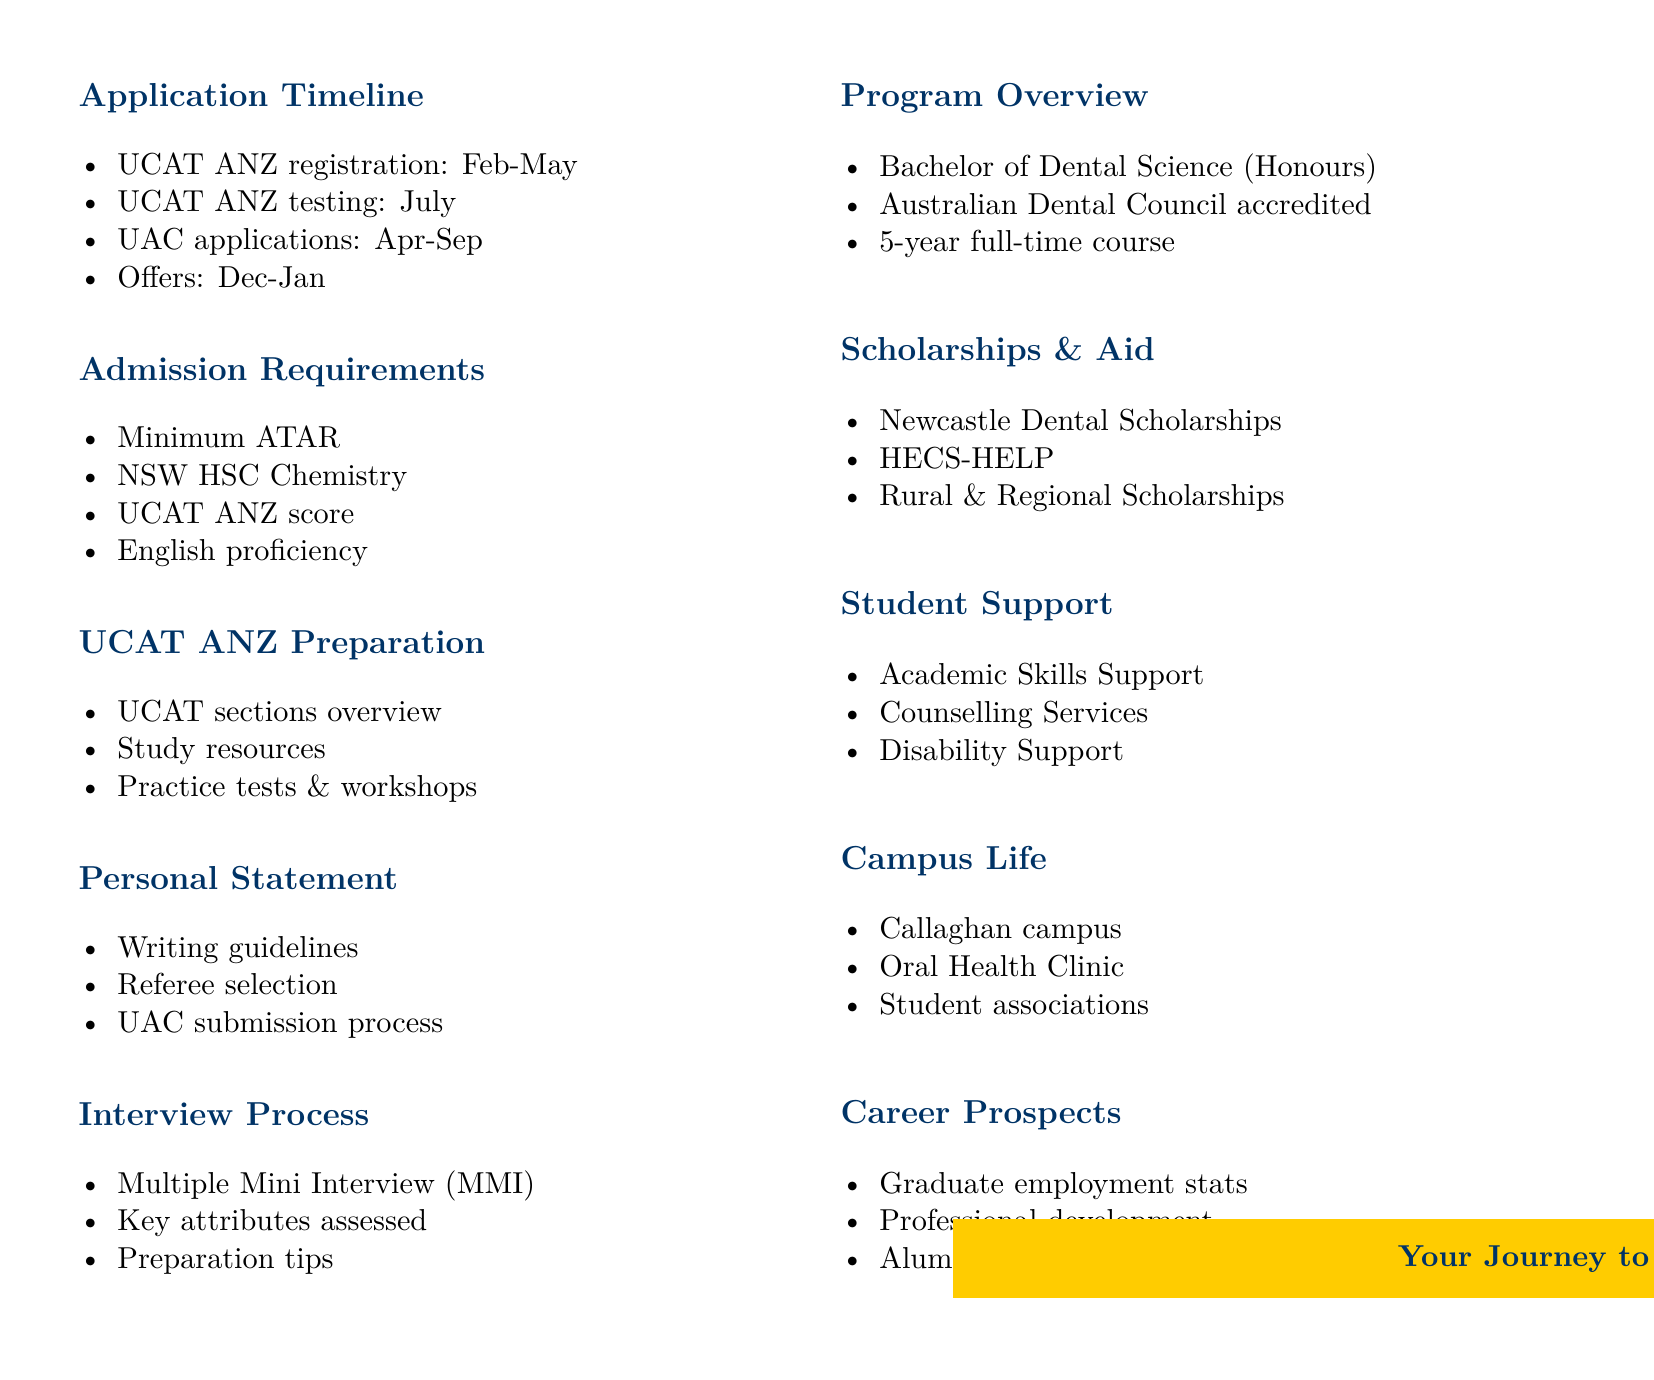What is the total duration of the Bachelor of Dental Science program? The total duration is mentioned in the section detailing the program overview as a five-year full-time course.
Answer: Five years When do UCAT ANZ applications open? The document states that UAC applications open in April.
Answer: April What is required alongside the minimum ATAR for admission? The details indicate that Completion of NSW HSC Chemistry (or equivalent) is a requirement alongside the minimum ATAR.
Answer: Completion of NSW HSC Chemistry What is the format of the interview process? The document outlines the interview process format as Multiple Mini Interview (MMI).
Answer: Multiple Mini Interview (MMI) What type of support services are offered to students? The document lists several types of support services offered, including Academic Skills Support.
Answer: Academic Skills Support 